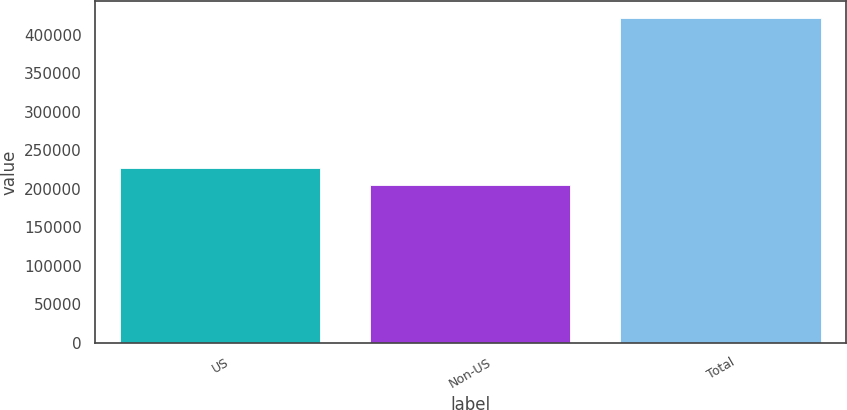Convert chart to OTSL. <chart><loc_0><loc_0><loc_500><loc_500><bar_chart><fcel>US<fcel>Non-US<fcel>Total<nl><fcel>226538<fcel>204798<fcel>422196<nl></chart> 